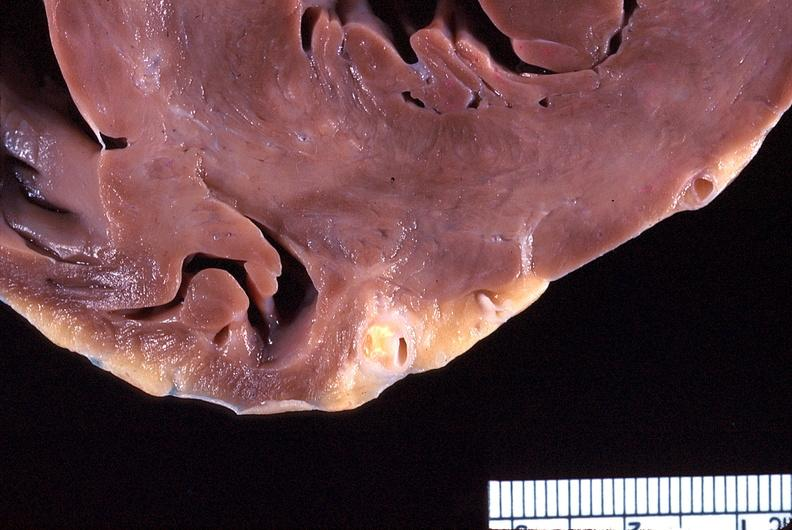what does this image show?
Answer the question using a single word or phrase. Heart 